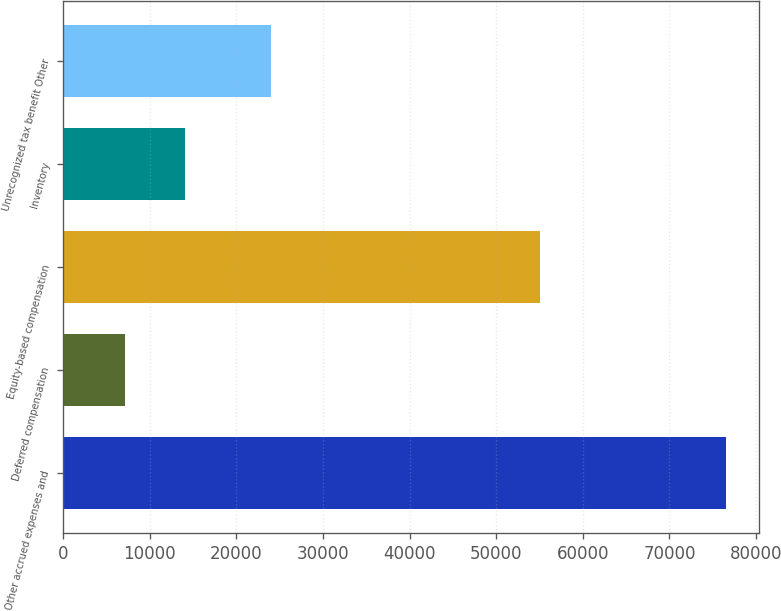Convert chart. <chart><loc_0><loc_0><loc_500><loc_500><bar_chart><fcel>Other accrued expenses and<fcel>Deferred compensation<fcel>Equity-based compensation<fcel>Inventory<fcel>Unrecognized tax benefit Other<nl><fcel>76498<fcel>7075<fcel>55077<fcel>14017.3<fcel>23954<nl></chart> 